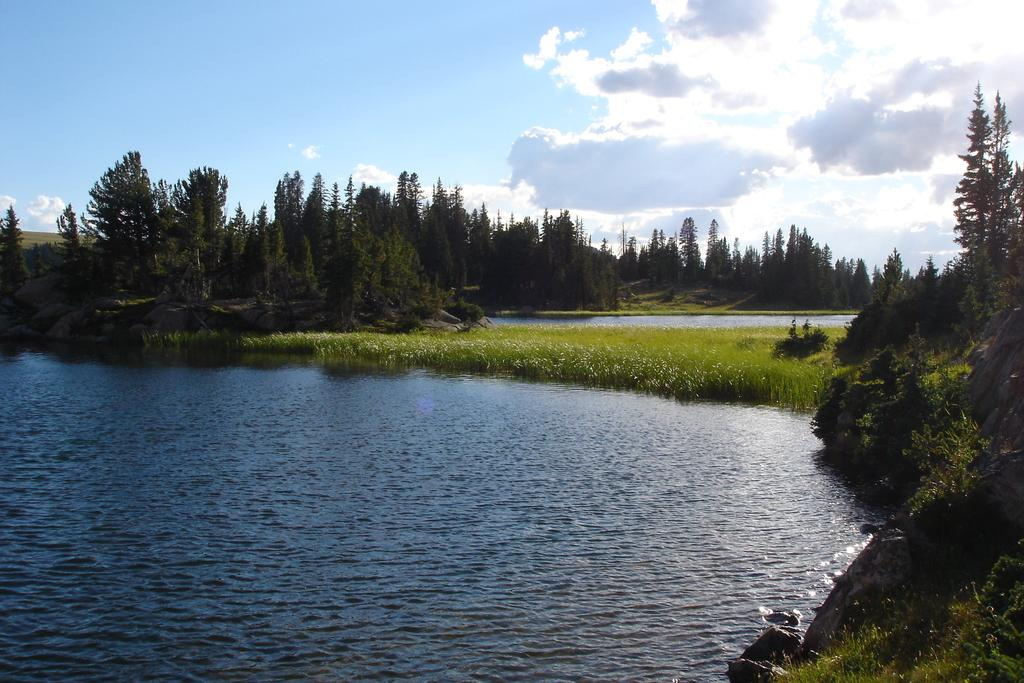What can be seen in the sky in the image? The sky with clouds is visible in the image. What type of vegetation is present in the image? There are trees in the image, and grass is also present. What other natural elements can be seen in the image? Rocks and water are visible in the image. How many cars are parked on the grass in the image? There are no cars present in the image; it features natural elements such as trees, grass, rocks, and water. What type of whip is being used to control the water in the image? There is no whip present in the image, and the water is not being controlled by any visible object or person. 